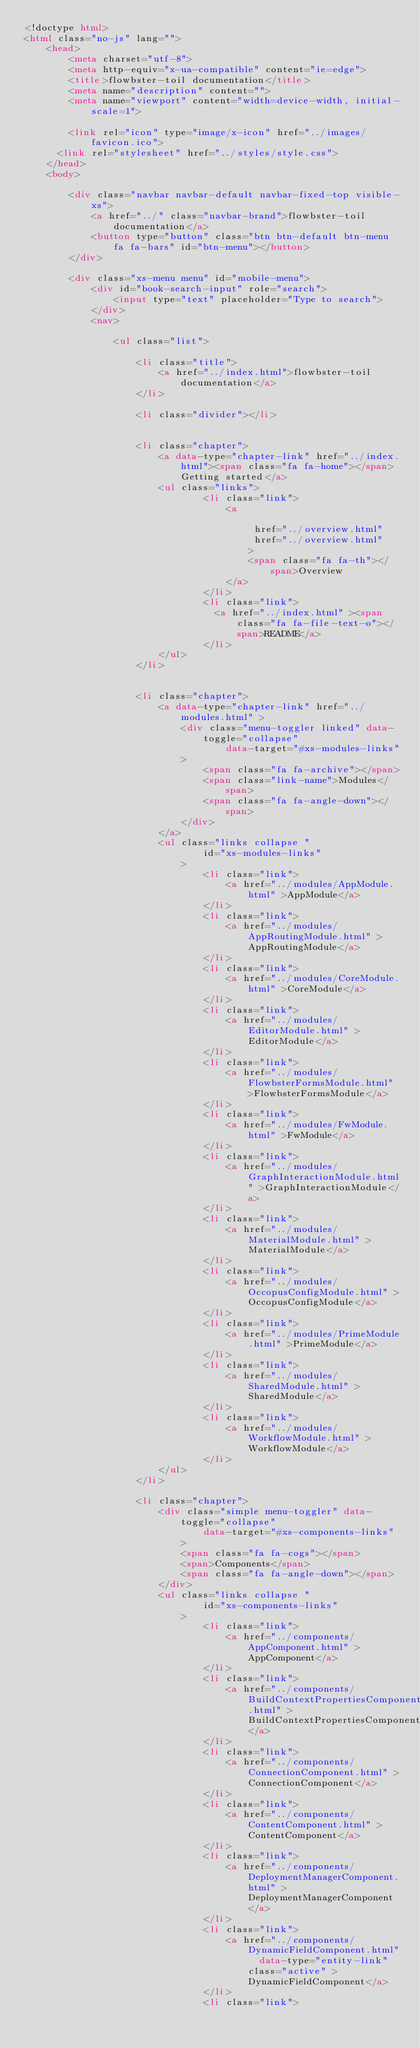Convert code to text. <code><loc_0><loc_0><loc_500><loc_500><_HTML_><!doctype html>
<html class="no-js" lang="">
    <head>
        <meta charset="utf-8">
        <meta http-equiv="x-ua-compatible" content="ie=edge">
        <title>flowbster-toil documentation</title>
        <meta name="description" content="">
        <meta name="viewport" content="width=device-width, initial-scale=1">

        <link rel="icon" type="image/x-icon" href="../images/favicon.ico">
	    <link rel="stylesheet" href="../styles/style.css">
    </head>
    <body>

        <div class="navbar navbar-default navbar-fixed-top visible-xs">
            <a href="../" class="navbar-brand">flowbster-toil documentation</a>
            <button type="button" class="btn btn-default btn-menu fa fa-bars" id="btn-menu"></button>
        </div>

        <div class="xs-menu menu" id="mobile-menu">
            <div id="book-search-input" role="search">
                <input type="text" placeholder="Type to search">
            </div>
            <nav>
            
                <ul class="list">
            
                    <li class="title">
                        <a href="../index.html">flowbster-toil documentation</a>
                    </li>
            
                    <li class="divider"></li>
            
            
                    <li class="chapter">
                        <a data-type="chapter-link" href="../index.html"><span class="fa fa-home"></span>Getting started</a>
                        <ul class="links">
                                <li class="link">
                                    <a 
                                        
                                         href="../overview.html" 
                                         href="../overview.html" 
                                        >
                                        <span class="fa fa-th"></span>Overview
                                    </a>
                                </li>
                                <li class="link">
                                  <a href="../index.html" ><span class="fa fa-file-text-o"></span>README</a>
                                </li>
                        </ul>
                    </li>
            
            
                    <li class="chapter">
                        <a data-type="chapter-link" href="../modules.html" >
                            <div class="menu-toggler linked" data-toggle="collapse"
                                    data-target="#xs-modules-links"
                            >
                                <span class="fa fa-archive"></span>
                                <span class="link-name">Modules</span>
                                <span class="fa fa-angle-down"></span>
                            </div>
                        </a>
                        <ul class="links collapse "
                                id="xs-modules-links"
                            >
                                <li class="link">
                                    <a href="../modules/AppModule.html" >AppModule</a>
                                </li>
                                <li class="link">
                                    <a href="../modules/AppRoutingModule.html" >AppRoutingModule</a>
                                </li>
                                <li class="link">
                                    <a href="../modules/CoreModule.html" >CoreModule</a>
                                </li>
                                <li class="link">
                                    <a href="../modules/EditorModule.html" >EditorModule</a>
                                </li>
                                <li class="link">
                                    <a href="../modules/FlowbsterFormsModule.html" >FlowbsterFormsModule</a>
                                </li>
                                <li class="link">
                                    <a href="../modules/FwModule.html" >FwModule</a>
                                </li>
                                <li class="link">
                                    <a href="../modules/GraphInteractionModule.html" >GraphInteractionModule</a>
                                </li>
                                <li class="link">
                                    <a href="../modules/MaterialModule.html" >MaterialModule</a>
                                </li>
                                <li class="link">
                                    <a href="../modules/OccopusConfigModule.html" >OccopusConfigModule</a>
                                </li>
                                <li class="link">
                                    <a href="../modules/PrimeModule.html" >PrimeModule</a>
                                </li>
                                <li class="link">
                                    <a href="../modules/SharedModule.html" >SharedModule</a>
                                </li>
                                <li class="link">
                                    <a href="../modules/WorkflowModule.html" >WorkflowModule</a>
                                </li>
                        </ul>
                    </li>
            
                    <li class="chapter">
                        <div class="simple menu-toggler" data-toggle="collapse"
                                data-target="#xs-components-links"
                            >
                            <span class="fa fa-cogs"></span>
                            <span>Components</span>
                            <span class="fa fa-angle-down"></span>
                        </div>
                        <ul class="links collapse "
                                id="xs-components-links"
                            >
                                <li class="link">
                                    <a href="../components/AppComponent.html" >AppComponent</a>
                                </li>
                                <li class="link">
                                    <a href="../components/BuildContextPropertiesComponent.html" >BuildContextPropertiesComponent</a>
                                </li>
                                <li class="link">
                                    <a href="../components/ConnectionComponent.html" >ConnectionComponent</a>
                                </li>
                                <li class="link">
                                    <a href="../components/ContentComponent.html" >ContentComponent</a>
                                </li>
                                <li class="link">
                                    <a href="../components/DeploymentManagerComponent.html" >DeploymentManagerComponent</a>
                                </li>
                                <li class="link">
                                    <a href="../components/DynamicFieldComponent.html"  data-type="entity-link" class="active" >DynamicFieldComponent</a>
                                </li>
                                <li class="link"></code> 